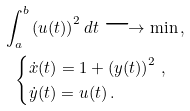Convert formula to latex. <formula><loc_0><loc_0><loc_500><loc_500>\int _ { a } ^ { b } \left ( u ( t ) \right ) ^ { 2 } d t \longrightarrow \min \, , \\ \begin{cases} \dot { x } ( t ) = 1 + \left ( y ( t ) \right ) ^ { 2 } \, , \\ \dot { y } ( t ) = u ( t ) \, . \end{cases}</formula> 